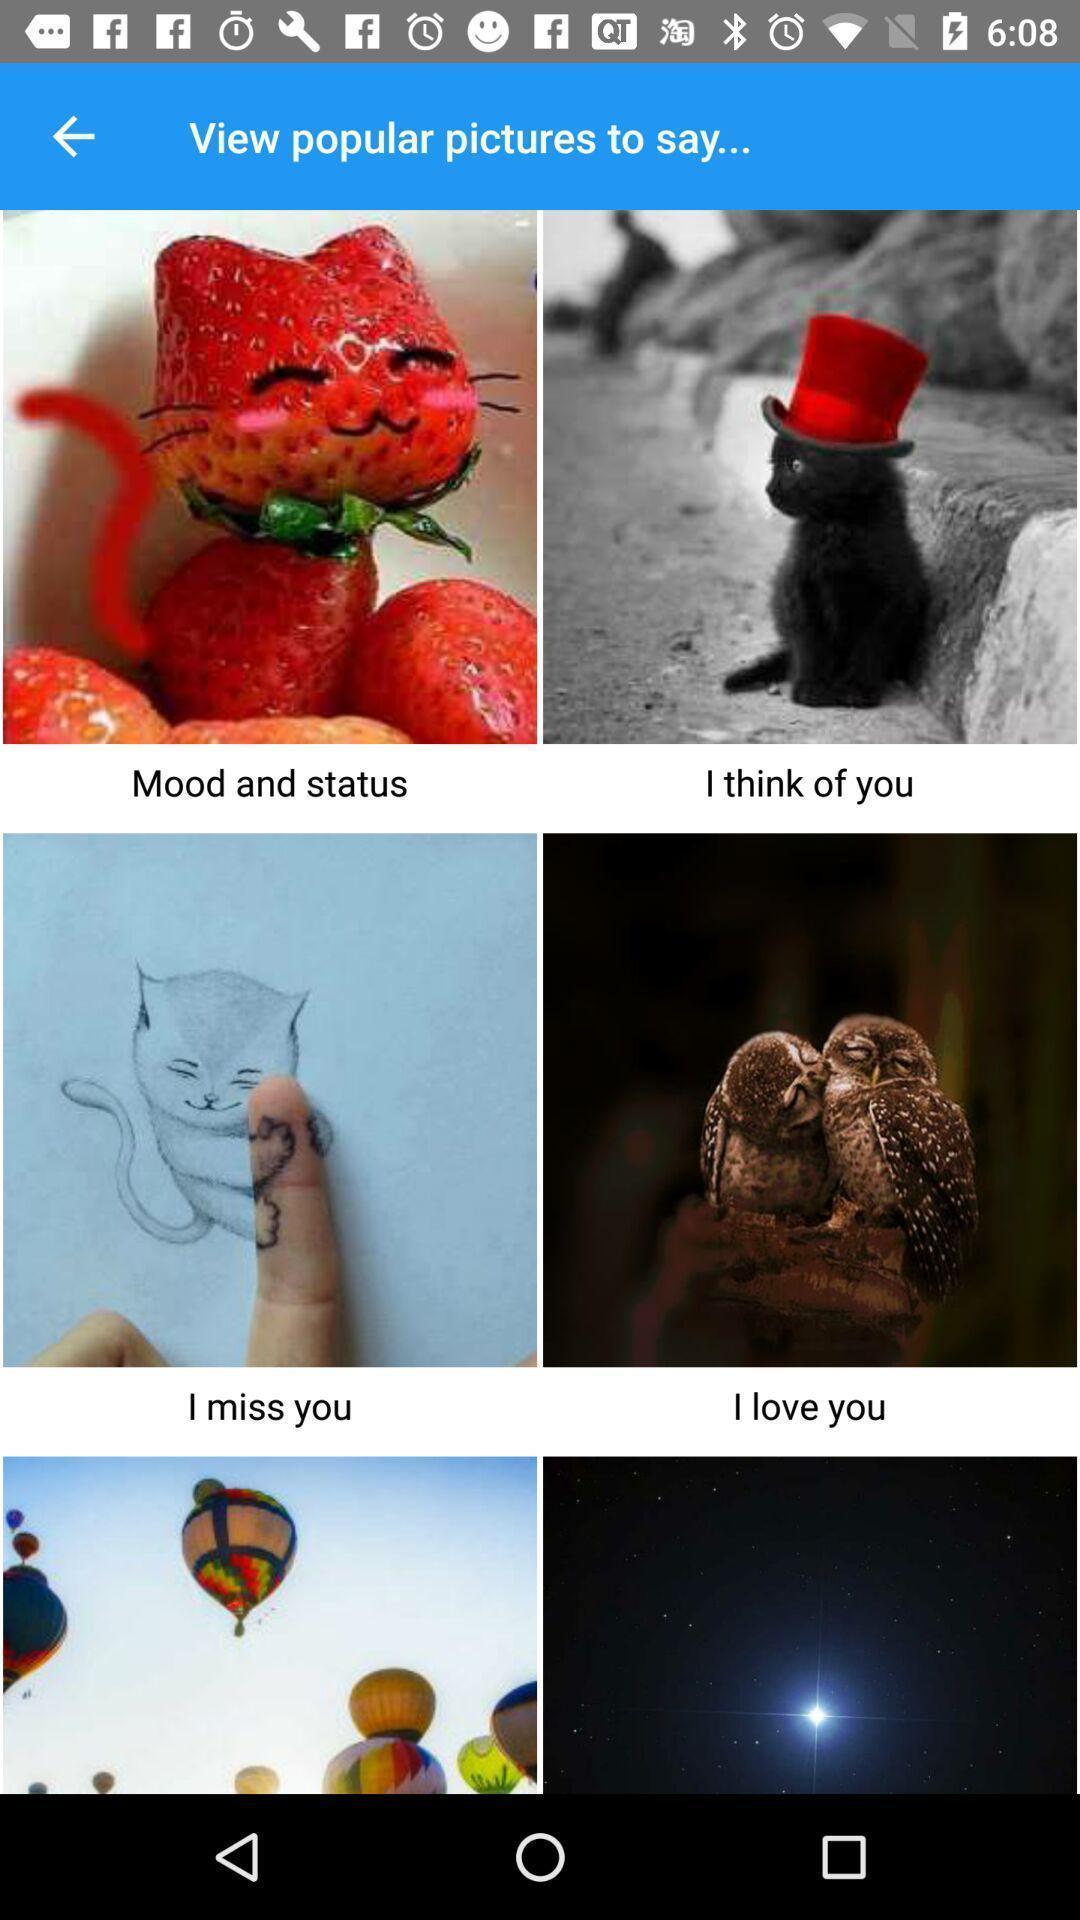Summarize the information in this screenshot. Page displaying the view of profile pictures. 